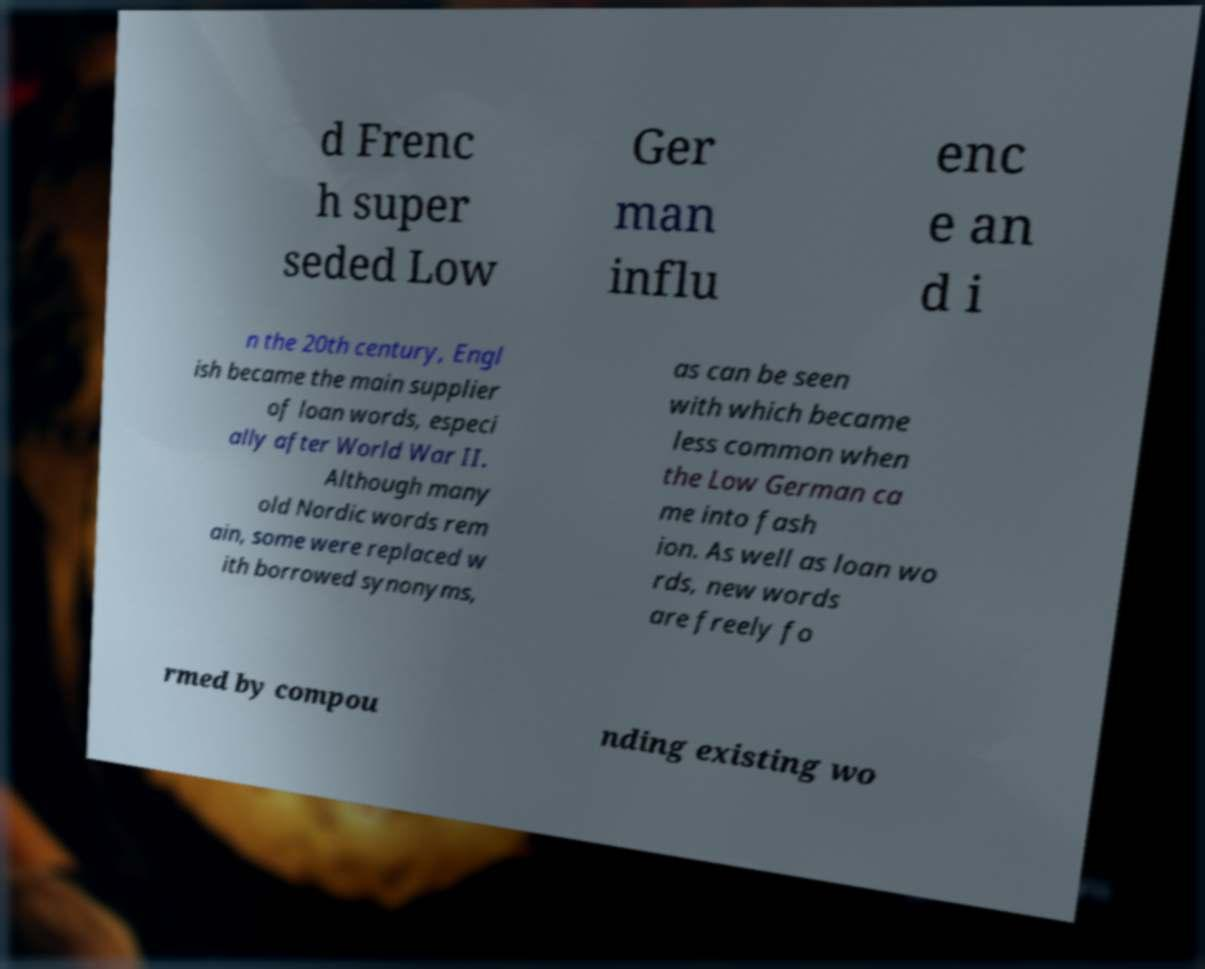There's text embedded in this image that I need extracted. Can you transcribe it verbatim? d Frenc h super seded Low Ger man influ enc e an d i n the 20th century, Engl ish became the main supplier of loan words, especi ally after World War II. Although many old Nordic words rem ain, some were replaced w ith borrowed synonyms, as can be seen with which became less common when the Low German ca me into fash ion. As well as loan wo rds, new words are freely fo rmed by compou nding existing wo 